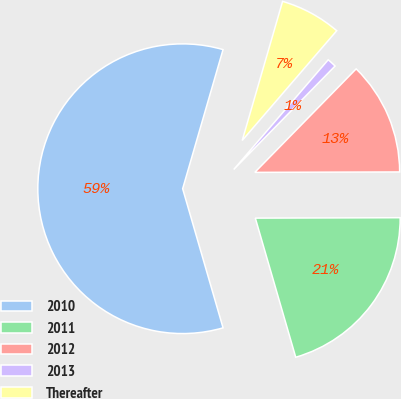Convert chart. <chart><loc_0><loc_0><loc_500><loc_500><pie_chart><fcel>2010<fcel>2011<fcel>2012<fcel>2013<fcel>Thereafter<nl><fcel>59.0%<fcel>20.55%<fcel>12.62%<fcel>1.02%<fcel>6.82%<nl></chart> 